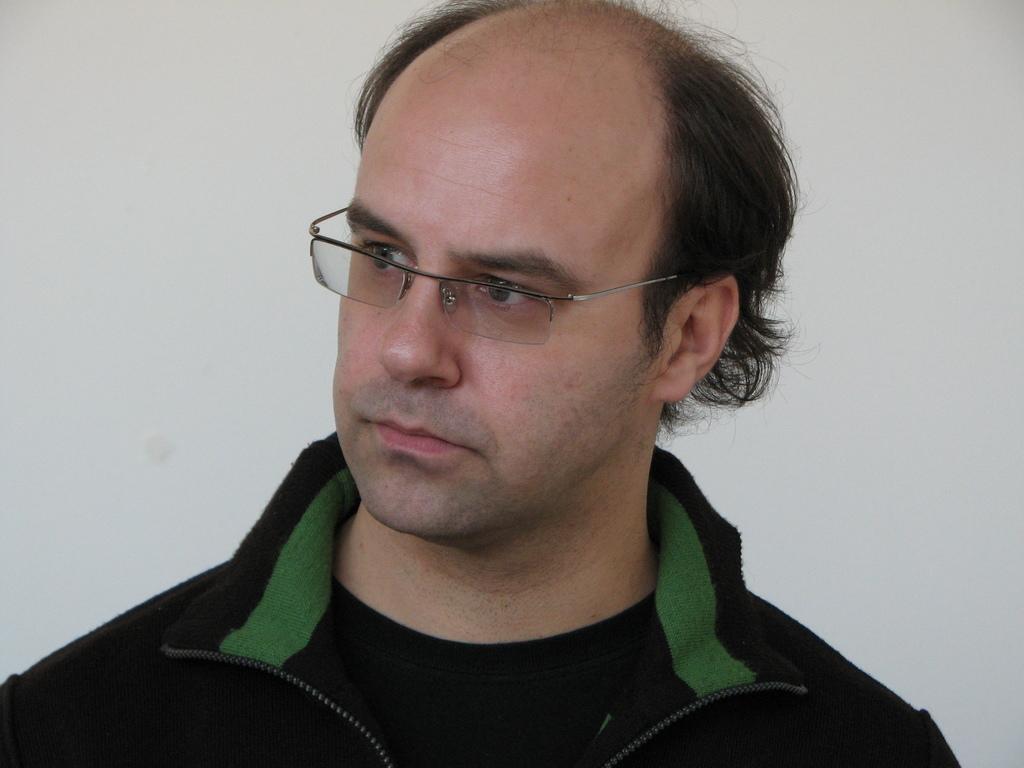Could you give a brief overview of what you see in this image? In the middle of this image, there is a person in a black color jacket, watching something. And the background is white in color. 